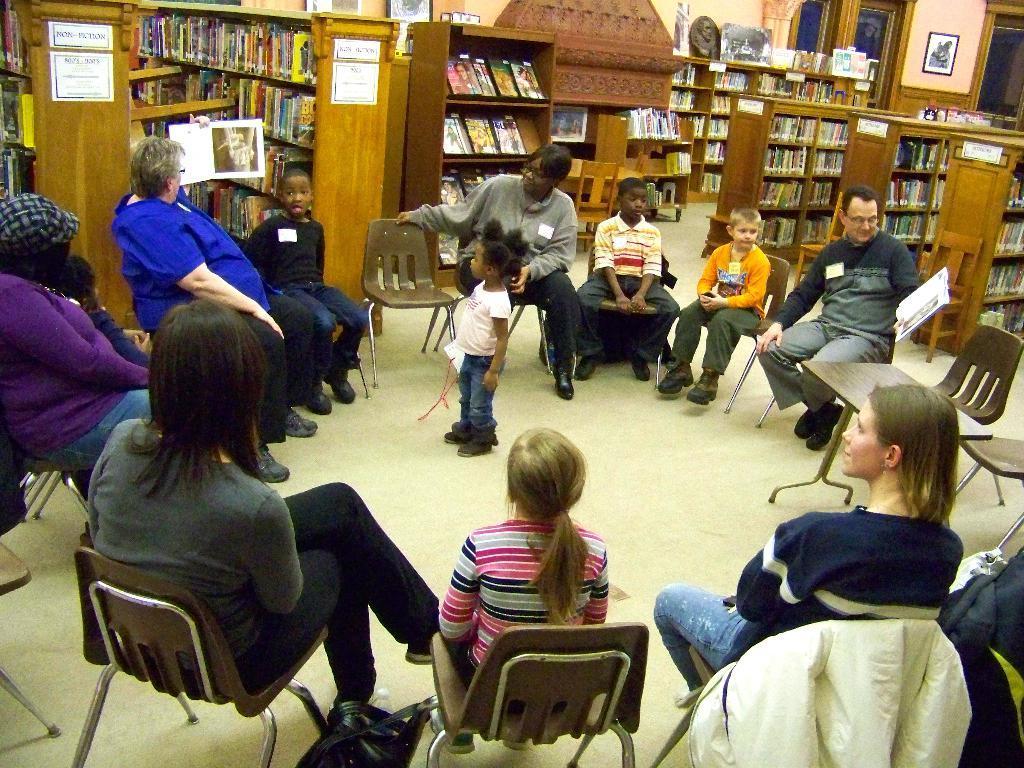Could you give a brief overview of what you see in this image? In this picture there are group of people who are sitting on the chair. There is a little girl wearing a pink top is standing. There are plenty of books which are arranged in the shelf. There is a frame on the wall. There is an idol on the shelf. 